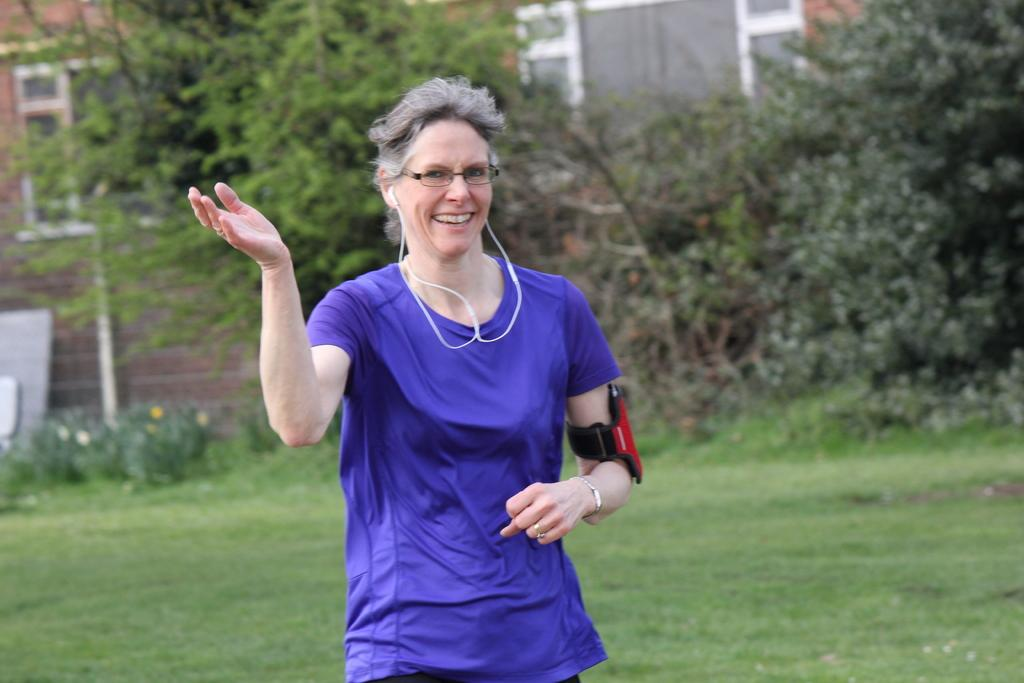Who is the main subject in the image? There is a lady in the center of the image. What is the lady doing in the image? The lady is standing in the image. What is the lady's facial expression in the image? The lady is smiling in the image. What can be seen in the background of the image? There are buildings, trees, and grass in the background of the image. Is the lady wearing a coat in the image? There is no mention of a coat in the image, so we cannot determine if the lady is wearing one. Can you tell me how many times the lady jumps in the image? The lady is not jumping in the image; she is standing. 